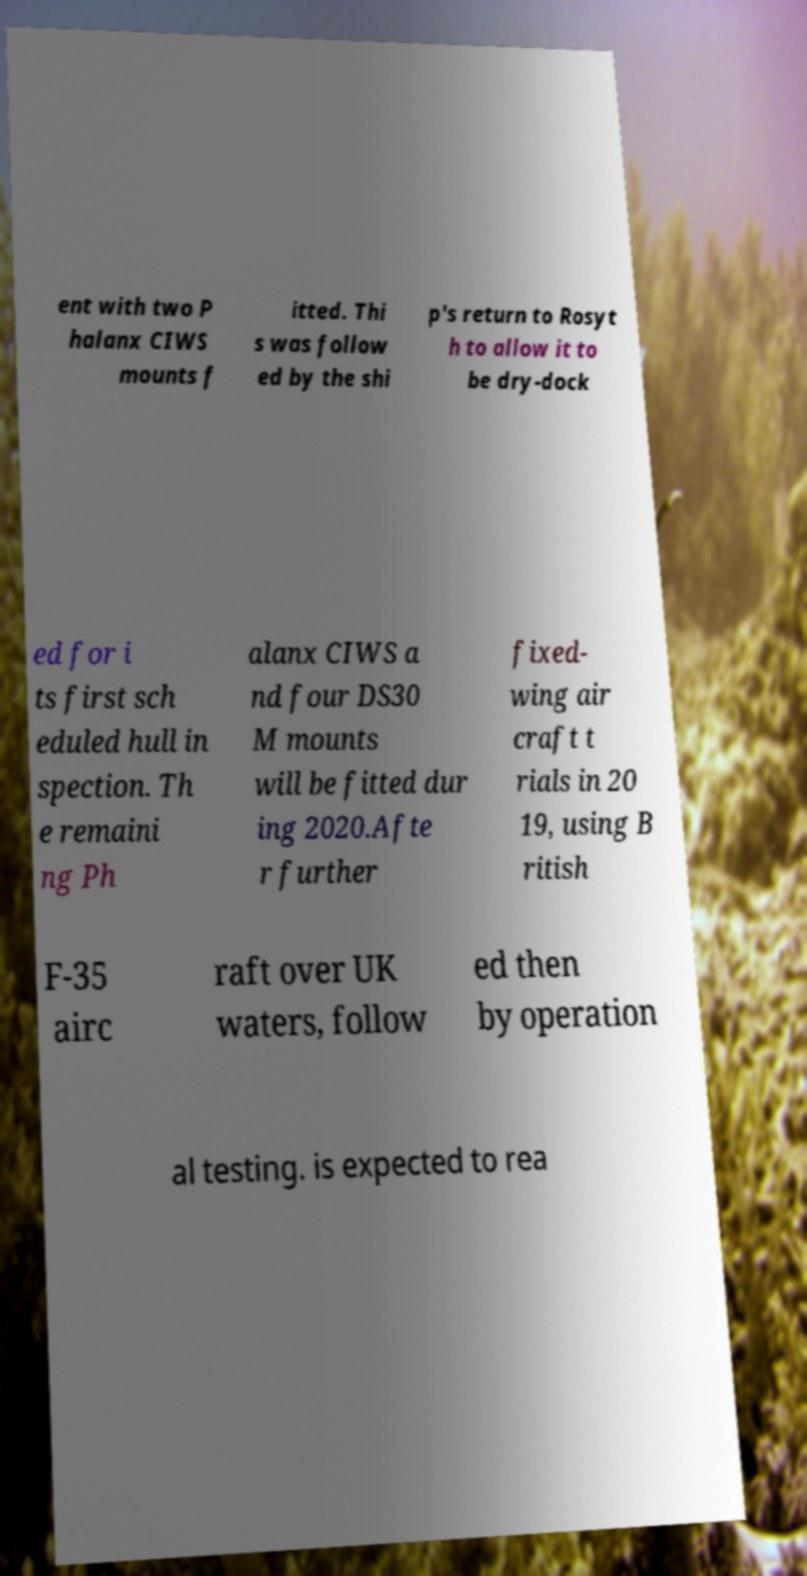There's text embedded in this image that I need extracted. Can you transcribe it verbatim? ent with two P halanx CIWS mounts f itted. Thi s was follow ed by the shi p's return to Rosyt h to allow it to be dry-dock ed for i ts first sch eduled hull in spection. Th e remaini ng Ph alanx CIWS a nd four DS30 M mounts will be fitted dur ing 2020.Afte r further fixed- wing air craft t rials in 20 19, using B ritish F-35 airc raft over UK waters, follow ed then by operation al testing. is expected to rea 